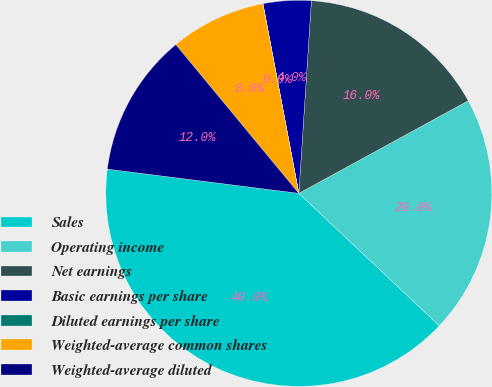Convert chart. <chart><loc_0><loc_0><loc_500><loc_500><pie_chart><fcel>Sales<fcel>Operating income<fcel>Net earnings<fcel>Basic earnings per share<fcel>Diluted earnings per share<fcel>Weighted-average common shares<fcel>Weighted-average diluted<nl><fcel>39.97%<fcel>19.99%<fcel>16.0%<fcel>4.01%<fcel>0.01%<fcel>8.01%<fcel>12.0%<nl></chart> 